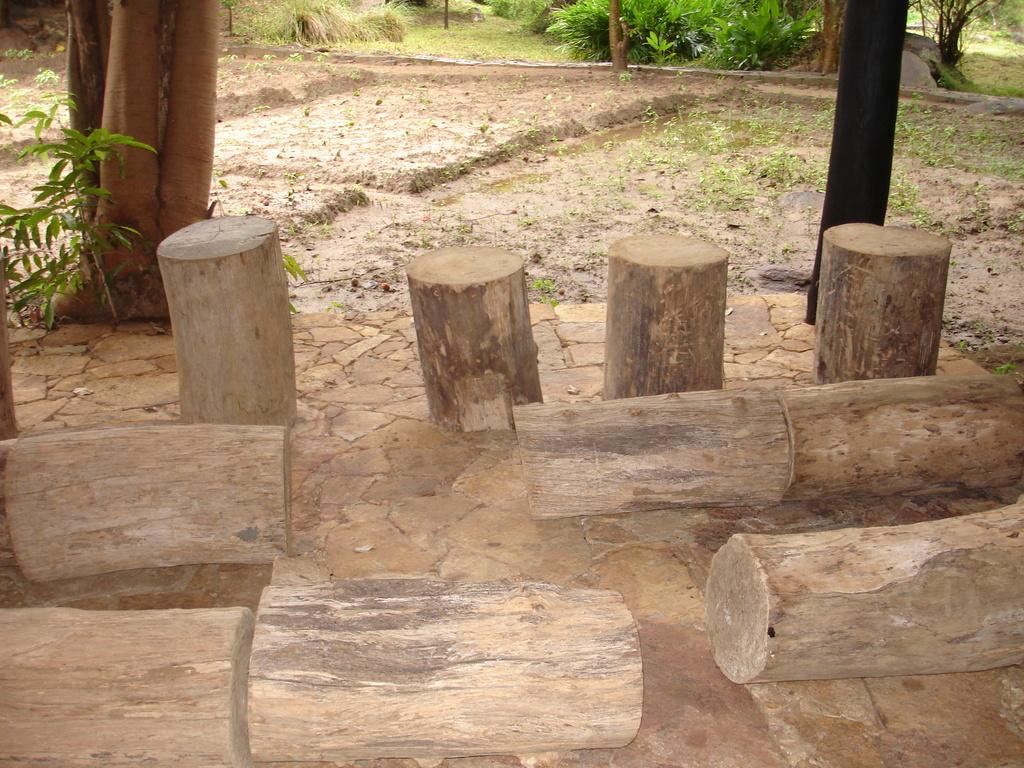Could you give a brief overview of what you see in this image? In this picture there are bamboos in the center of the image and there are plants at the top side of the image. 